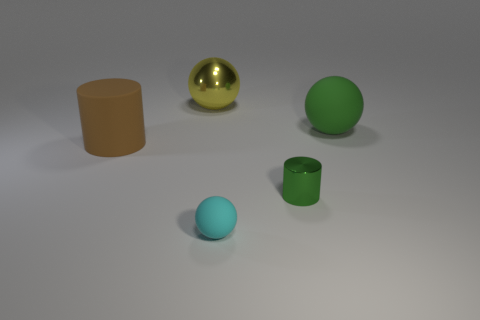Can you tell me about the objects' sizes relative to one another? Certainly. In the image, we have objects of varying sizes. Starting with the smallest, there's a cyan-colored sphere which is the tiniest. Following that in ascending order, we have a green cylindrical cup, a gold spherical object, and the largest is a brown cylindrical shape that looks like a container without a lid. 